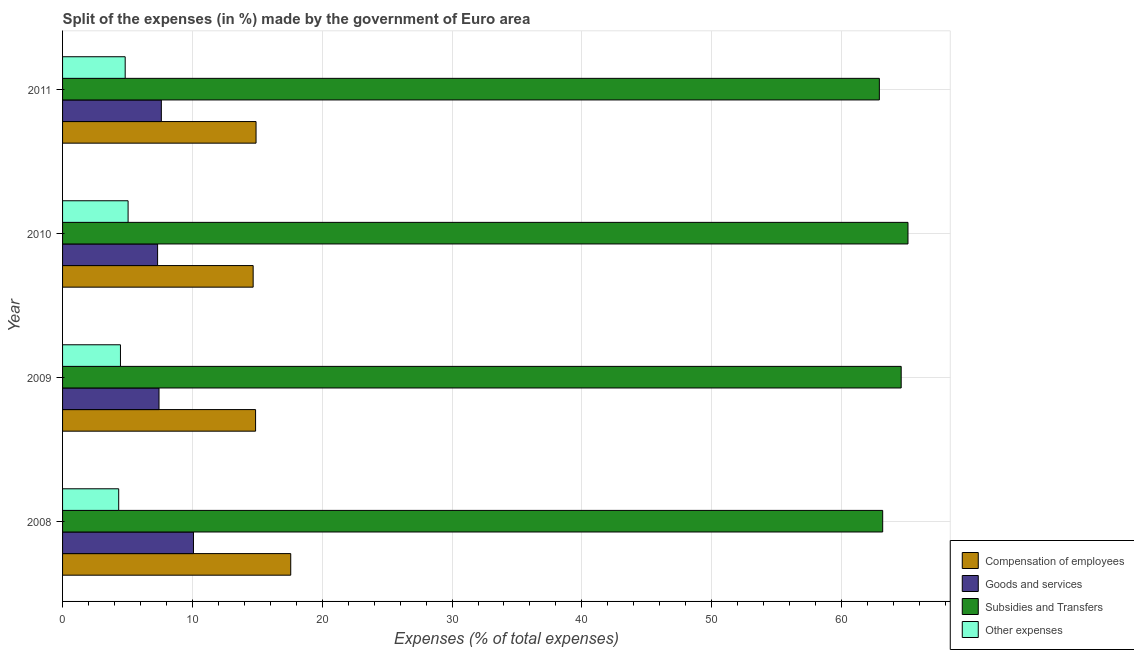How many groups of bars are there?
Ensure brevity in your answer.  4. Are the number of bars per tick equal to the number of legend labels?
Make the answer very short. Yes. How many bars are there on the 1st tick from the top?
Your answer should be very brief. 4. How many bars are there on the 2nd tick from the bottom?
Your answer should be very brief. 4. What is the percentage of amount spent on compensation of employees in 2008?
Make the answer very short. 17.57. Across all years, what is the maximum percentage of amount spent on compensation of employees?
Make the answer very short. 17.57. Across all years, what is the minimum percentage of amount spent on goods and services?
Give a very brief answer. 7.32. In which year was the percentage of amount spent on goods and services minimum?
Offer a terse response. 2010. What is the total percentage of amount spent on compensation of employees in the graph?
Your answer should be compact. 62.03. What is the difference between the percentage of amount spent on other expenses in 2008 and that in 2009?
Ensure brevity in your answer.  -0.14. What is the difference between the percentage of amount spent on subsidies in 2009 and the percentage of amount spent on other expenses in 2011?
Provide a succinct answer. 59.77. What is the average percentage of amount spent on subsidies per year?
Ensure brevity in your answer.  63.95. In the year 2010, what is the difference between the percentage of amount spent on goods and services and percentage of amount spent on compensation of employees?
Your response must be concise. -7.36. What is the ratio of the percentage of amount spent on goods and services in 2009 to that in 2011?
Ensure brevity in your answer.  0.98. Is the percentage of amount spent on compensation of employees in 2009 less than that in 2011?
Your answer should be very brief. Yes. What is the difference between the highest and the second highest percentage of amount spent on other expenses?
Your response must be concise. 0.22. What is the difference between the highest and the lowest percentage of amount spent on other expenses?
Your answer should be compact. 0.72. In how many years, is the percentage of amount spent on goods and services greater than the average percentage of amount spent on goods and services taken over all years?
Ensure brevity in your answer.  1. Is the sum of the percentage of amount spent on compensation of employees in 2009 and 2010 greater than the maximum percentage of amount spent on subsidies across all years?
Make the answer very short. No. What does the 4th bar from the top in 2009 represents?
Make the answer very short. Compensation of employees. What does the 1st bar from the bottom in 2009 represents?
Offer a terse response. Compensation of employees. Is it the case that in every year, the sum of the percentage of amount spent on compensation of employees and percentage of amount spent on goods and services is greater than the percentage of amount spent on subsidies?
Your answer should be very brief. No. Are all the bars in the graph horizontal?
Your answer should be very brief. Yes. How many years are there in the graph?
Give a very brief answer. 4. What is the difference between two consecutive major ticks on the X-axis?
Your answer should be compact. 10. Does the graph contain any zero values?
Your answer should be compact. No. Where does the legend appear in the graph?
Your answer should be compact. Bottom right. What is the title of the graph?
Provide a succinct answer. Split of the expenses (in %) made by the government of Euro area. What is the label or title of the X-axis?
Offer a terse response. Expenses (% of total expenses). What is the Expenses (% of total expenses) in Compensation of employees in 2008?
Ensure brevity in your answer.  17.57. What is the Expenses (% of total expenses) of Goods and services in 2008?
Keep it short and to the point. 10.08. What is the Expenses (% of total expenses) in Subsidies and Transfers in 2008?
Give a very brief answer. 63.17. What is the Expenses (% of total expenses) in Other expenses in 2008?
Give a very brief answer. 4.32. What is the Expenses (% of total expenses) in Compensation of employees in 2009?
Your answer should be very brief. 14.87. What is the Expenses (% of total expenses) in Goods and services in 2009?
Provide a succinct answer. 7.43. What is the Expenses (% of total expenses) of Subsidies and Transfers in 2009?
Ensure brevity in your answer.  64.59. What is the Expenses (% of total expenses) in Other expenses in 2009?
Provide a short and direct response. 4.46. What is the Expenses (% of total expenses) of Compensation of employees in 2010?
Provide a short and direct response. 14.68. What is the Expenses (% of total expenses) in Goods and services in 2010?
Ensure brevity in your answer.  7.32. What is the Expenses (% of total expenses) in Subsidies and Transfers in 2010?
Provide a short and direct response. 65.12. What is the Expenses (% of total expenses) in Other expenses in 2010?
Make the answer very short. 5.05. What is the Expenses (% of total expenses) in Compensation of employees in 2011?
Your response must be concise. 14.9. What is the Expenses (% of total expenses) of Goods and services in 2011?
Your response must be concise. 7.61. What is the Expenses (% of total expenses) in Subsidies and Transfers in 2011?
Ensure brevity in your answer.  62.91. What is the Expenses (% of total expenses) in Other expenses in 2011?
Give a very brief answer. 4.82. Across all years, what is the maximum Expenses (% of total expenses) of Compensation of employees?
Keep it short and to the point. 17.57. Across all years, what is the maximum Expenses (% of total expenses) of Goods and services?
Your answer should be compact. 10.08. Across all years, what is the maximum Expenses (% of total expenses) of Subsidies and Transfers?
Offer a very short reply. 65.12. Across all years, what is the maximum Expenses (% of total expenses) in Other expenses?
Give a very brief answer. 5.05. Across all years, what is the minimum Expenses (% of total expenses) in Compensation of employees?
Give a very brief answer. 14.68. Across all years, what is the minimum Expenses (% of total expenses) in Goods and services?
Your answer should be compact. 7.32. Across all years, what is the minimum Expenses (% of total expenses) of Subsidies and Transfers?
Your answer should be very brief. 62.91. Across all years, what is the minimum Expenses (% of total expenses) in Other expenses?
Give a very brief answer. 4.32. What is the total Expenses (% of total expenses) in Compensation of employees in the graph?
Offer a very short reply. 62.03. What is the total Expenses (% of total expenses) of Goods and services in the graph?
Your response must be concise. 32.44. What is the total Expenses (% of total expenses) in Subsidies and Transfers in the graph?
Provide a succinct answer. 255.8. What is the total Expenses (% of total expenses) of Other expenses in the graph?
Provide a succinct answer. 18.65. What is the difference between the Expenses (% of total expenses) in Compensation of employees in 2008 and that in 2009?
Your answer should be compact. 2.71. What is the difference between the Expenses (% of total expenses) in Goods and services in 2008 and that in 2009?
Your answer should be compact. 2.65. What is the difference between the Expenses (% of total expenses) of Subsidies and Transfers in 2008 and that in 2009?
Ensure brevity in your answer.  -1.42. What is the difference between the Expenses (% of total expenses) in Other expenses in 2008 and that in 2009?
Offer a terse response. -0.13. What is the difference between the Expenses (% of total expenses) in Compensation of employees in 2008 and that in 2010?
Your answer should be very brief. 2.89. What is the difference between the Expenses (% of total expenses) of Goods and services in 2008 and that in 2010?
Give a very brief answer. 2.76. What is the difference between the Expenses (% of total expenses) of Subsidies and Transfers in 2008 and that in 2010?
Provide a short and direct response. -1.95. What is the difference between the Expenses (% of total expenses) of Other expenses in 2008 and that in 2010?
Your answer should be compact. -0.72. What is the difference between the Expenses (% of total expenses) in Compensation of employees in 2008 and that in 2011?
Your answer should be very brief. 2.67. What is the difference between the Expenses (% of total expenses) of Goods and services in 2008 and that in 2011?
Ensure brevity in your answer.  2.47. What is the difference between the Expenses (% of total expenses) in Subsidies and Transfers in 2008 and that in 2011?
Make the answer very short. 0.26. What is the difference between the Expenses (% of total expenses) in Other expenses in 2008 and that in 2011?
Give a very brief answer. -0.5. What is the difference between the Expenses (% of total expenses) of Compensation of employees in 2009 and that in 2010?
Offer a terse response. 0.19. What is the difference between the Expenses (% of total expenses) of Goods and services in 2009 and that in 2010?
Provide a succinct answer. 0.11. What is the difference between the Expenses (% of total expenses) in Subsidies and Transfers in 2009 and that in 2010?
Offer a terse response. -0.52. What is the difference between the Expenses (% of total expenses) of Other expenses in 2009 and that in 2010?
Make the answer very short. -0.59. What is the difference between the Expenses (% of total expenses) in Compensation of employees in 2009 and that in 2011?
Provide a short and direct response. -0.04. What is the difference between the Expenses (% of total expenses) of Goods and services in 2009 and that in 2011?
Your answer should be very brief. -0.18. What is the difference between the Expenses (% of total expenses) in Subsidies and Transfers in 2009 and that in 2011?
Give a very brief answer. 1.68. What is the difference between the Expenses (% of total expenses) in Other expenses in 2009 and that in 2011?
Provide a succinct answer. -0.36. What is the difference between the Expenses (% of total expenses) in Compensation of employees in 2010 and that in 2011?
Make the answer very short. -0.22. What is the difference between the Expenses (% of total expenses) of Goods and services in 2010 and that in 2011?
Offer a terse response. -0.29. What is the difference between the Expenses (% of total expenses) in Subsidies and Transfers in 2010 and that in 2011?
Offer a terse response. 2.21. What is the difference between the Expenses (% of total expenses) in Other expenses in 2010 and that in 2011?
Give a very brief answer. 0.22. What is the difference between the Expenses (% of total expenses) of Compensation of employees in 2008 and the Expenses (% of total expenses) of Goods and services in 2009?
Provide a short and direct response. 10.15. What is the difference between the Expenses (% of total expenses) in Compensation of employees in 2008 and the Expenses (% of total expenses) in Subsidies and Transfers in 2009?
Make the answer very short. -47.02. What is the difference between the Expenses (% of total expenses) in Compensation of employees in 2008 and the Expenses (% of total expenses) in Other expenses in 2009?
Offer a terse response. 13.12. What is the difference between the Expenses (% of total expenses) of Goods and services in 2008 and the Expenses (% of total expenses) of Subsidies and Transfers in 2009?
Your answer should be compact. -54.51. What is the difference between the Expenses (% of total expenses) in Goods and services in 2008 and the Expenses (% of total expenses) in Other expenses in 2009?
Ensure brevity in your answer.  5.62. What is the difference between the Expenses (% of total expenses) of Subsidies and Transfers in 2008 and the Expenses (% of total expenses) of Other expenses in 2009?
Your answer should be very brief. 58.71. What is the difference between the Expenses (% of total expenses) of Compensation of employees in 2008 and the Expenses (% of total expenses) of Goods and services in 2010?
Your response must be concise. 10.25. What is the difference between the Expenses (% of total expenses) in Compensation of employees in 2008 and the Expenses (% of total expenses) in Subsidies and Transfers in 2010?
Your answer should be compact. -47.54. What is the difference between the Expenses (% of total expenses) of Compensation of employees in 2008 and the Expenses (% of total expenses) of Other expenses in 2010?
Your answer should be very brief. 12.53. What is the difference between the Expenses (% of total expenses) in Goods and services in 2008 and the Expenses (% of total expenses) in Subsidies and Transfers in 2010?
Your answer should be compact. -55.04. What is the difference between the Expenses (% of total expenses) of Goods and services in 2008 and the Expenses (% of total expenses) of Other expenses in 2010?
Ensure brevity in your answer.  5.04. What is the difference between the Expenses (% of total expenses) of Subsidies and Transfers in 2008 and the Expenses (% of total expenses) of Other expenses in 2010?
Your response must be concise. 58.12. What is the difference between the Expenses (% of total expenses) of Compensation of employees in 2008 and the Expenses (% of total expenses) of Goods and services in 2011?
Your answer should be compact. 9.97. What is the difference between the Expenses (% of total expenses) in Compensation of employees in 2008 and the Expenses (% of total expenses) in Subsidies and Transfers in 2011?
Give a very brief answer. -45.34. What is the difference between the Expenses (% of total expenses) in Compensation of employees in 2008 and the Expenses (% of total expenses) in Other expenses in 2011?
Give a very brief answer. 12.75. What is the difference between the Expenses (% of total expenses) in Goods and services in 2008 and the Expenses (% of total expenses) in Subsidies and Transfers in 2011?
Make the answer very short. -52.83. What is the difference between the Expenses (% of total expenses) in Goods and services in 2008 and the Expenses (% of total expenses) in Other expenses in 2011?
Offer a very short reply. 5.26. What is the difference between the Expenses (% of total expenses) of Subsidies and Transfers in 2008 and the Expenses (% of total expenses) of Other expenses in 2011?
Offer a terse response. 58.35. What is the difference between the Expenses (% of total expenses) in Compensation of employees in 2009 and the Expenses (% of total expenses) in Goods and services in 2010?
Provide a short and direct response. 7.55. What is the difference between the Expenses (% of total expenses) of Compensation of employees in 2009 and the Expenses (% of total expenses) of Subsidies and Transfers in 2010?
Offer a very short reply. -50.25. What is the difference between the Expenses (% of total expenses) in Compensation of employees in 2009 and the Expenses (% of total expenses) in Other expenses in 2010?
Provide a short and direct response. 9.82. What is the difference between the Expenses (% of total expenses) in Goods and services in 2009 and the Expenses (% of total expenses) in Subsidies and Transfers in 2010?
Provide a short and direct response. -57.69. What is the difference between the Expenses (% of total expenses) in Goods and services in 2009 and the Expenses (% of total expenses) in Other expenses in 2010?
Make the answer very short. 2.38. What is the difference between the Expenses (% of total expenses) in Subsidies and Transfers in 2009 and the Expenses (% of total expenses) in Other expenses in 2010?
Ensure brevity in your answer.  59.55. What is the difference between the Expenses (% of total expenses) of Compensation of employees in 2009 and the Expenses (% of total expenses) of Goods and services in 2011?
Your response must be concise. 7.26. What is the difference between the Expenses (% of total expenses) of Compensation of employees in 2009 and the Expenses (% of total expenses) of Subsidies and Transfers in 2011?
Provide a short and direct response. -48.05. What is the difference between the Expenses (% of total expenses) of Compensation of employees in 2009 and the Expenses (% of total expenses) of Other expenses in 2011?
Give a very brief answer. 10.04. What is the difference between the Expenses (% of total expenses) of Goods and services in 2009 and the Expenses (% of total expenses) of Subsidies and Transfers in 2011?
Offer a very short reply. -55.48. What is the difference between the Expenses (% of total expenses) in Goods and services in 2009 and the Expenses (% of total expenses) in Other expenses in 2011?
Your answer should be compact. 2.61. What is the difference between the Expenses (% of total expenses) in Subsidies and Transfers in 2009 and the Expenses (% of total expenses) in Other expenses in 2011?
Offer a terse response. 59.77. What is the difference between the Expenses (% of total expenses) in Compensation of employees in 2010 and the Expenses (% of total expenses) in Goods and services in 2011?
Make the answer very short. 7.07. What is the difference between the Expenses (% of total expenses) of Compensation of employees in 2010 and the Expenses (% of total expenses) of Subsidies and Transfers in 2011?
Offer a very short reply. -48.23. What is the difference between the Expenses (% of total expenses) in Compensation of employees in 2010 and the Expenses (% of total expenses) in Other expenses in 2011?
Provide a short and direct response. 9.86. What is the difference between the Expenses (% of total expenses) in Goods and services in 2010 and the Expenses (% of total expenses) in Subsidies and Transfers in 2011?
Ensure brevity in your answer.  -55.59. What is the difference between the Expenses (% of total expenses) in Goods and services in 2010 and the Expenses (% of total expenses) in Other expenses in 2011?
Provide a short and direct response. 2.5. What is the difference between the Expenses (% of total expenses) of Subsidies and Transfers in 2010 and the Expenses (% of total expenses) of Other expenses in 2011?
Make the answer very short. 60.29. What is the average Expenses (% of total expenses) in Compensation of employees per year?
Make the answer very short. 15.51. What is the average Expenses (% of total expenses) of Goods and services per year?
Offer a terse response. 8.11. What is the average Expenses (% of total expenses) of Subsidies and Transfers per year?
Give a very brief answer. 63.95. What is the average Expenses (% of total expenses) in Other expenses per year?
Provide a succinct answer. 4.66. In the year 2008, what is the difference between the Expenses (% of total expenses) in Compensation of employees and Expenses (% of total expenses) in Goods and services?
Keep it short and to the point. 7.49. In the year 2008, what is the difference between the Expenses (% of total expenses) of Compensation of employees and Expenses (% of total expenses) of Subsidies and Transfers?
Keep it short and to the point. -45.6. In the year 2008, what is the difference between the Expenses (% of total expenses) of Compensation of employees and Expenses (% of total expenses) of Other expenses?
Keep it short and to the point. 13.25. In the year 2008, what is the difference between the Expenses (% of total expenses) in Goods and services and Expenses (% of total expenses) in Subsidies and Transfers?
Provide a short and direct response. -53.09. In the year 2008, what is the difference between the Expenses (% of total expenses) in Goods and services and Expenses (% of total expenses) in Other expenses?
Offer a very short reply. 5.76. In the year 2008, what is the difference between the Expenses (% of total expenses) in Subsidies and Transfers and Expenses (% of total expenses) in Other expenses?
Give a very brief answer. 58.85. In the year 2009, what is the difference between the Expenses (% of total expenses) of Compensation of employees and Expenses (% of total expenses) of Goods and services?
Your answer should be very brief. 7.44. In the year 2009, what is the difference between the Expenses (% of total expenses) in Compensation of employees and Expenses (% of total expenses) in Subsidies and Transfers?
Make the answer very short. -49.73. In the year 2009, what is the difference between the Expenses (% of total expenses) of Compensation of employees and Expenses (% of total expenses) of Other expenses?
Give a very brief answer. 10.41. In the year 2009, what is the difference between the Expenses (% of total expenses) of Goods and services and Expenses (% of total expenses) of Subsidies and Transfers?
Make the answer very short. -57.17. In the year 2009, what is the difference between the Expenses (% of total expenses) in Goods and services and Expenses (% of total expenses) in Other expenses?
Ensure brevity in your answer.  2.97. In the year 2009, what is the difference between the Expenses (% of total expenses) in Subsidies and Transfers and Expenses (% of total expenses) in Other expenses?
Provide a succinct answer. 60.14. In the year 2010, what is the difference between the Expenses (% of total expenses) in Compensation of employees and Expenses (% of total expenses) in Goods and services?
Your response must be concise. 7.36. In the year 2010, what is the difference between the Expenses (% of total expenses) in Compensation of employees and Expenses (% of total expenses) in Subsidies and Transfers?
Offer a terse response. -50.44. In the year 2010, what is the difference between the Expenses (% of total expenses) in Compensation of employees and Expenses (% of total expenses) in Other expenses?
Your response must be concise. 9.63. In the year 2010, what is the difference between the Expenses (% of total expenses) of Goods and services and Expenses (% of total expenses) of Subsidies and Transfers?
Ensure brevity in your answer.  -57.8. In the year 2010, what is the difference between the Expenses (% of total expenses) in Goods and services and Expenses (% of total expenses) in Other expenses?
Your response must be concise. 2.27. In the year 2010, what is the difference between the Expenses (% of total expenses) of Subsidies and Transfers and Expenses (% of total expenses) of Other expenses?
Give a very brief answer. 60.07. In the year 2011, what is the difference between the Expenses (% of total expenses) of Compensation of employees and Expenses (% of total expenses) of Goods and services?
Offer a terse response. 7.29. In the year 2011, what is the difference between the Expenses (% of total expenses) of Compensation of employees and Expenses (% of total expenses) of Subsidies and Transfers?
Offer a terse response. -48.01. In the year 2011, what is the difference between the Expenses (% of total expenses) of Compensation of employees and Expenses (% of total expenses) of Other expenses?
Provide a short and direct response. 10.08. In the year 2011, what is the difference between the Expenses (% of total expenses) of Goods and services and Expenses (% of total expenses) of Subsidies and Transfers?
Your response must be concise. -55.3. In the year 2011, what is the difference between the Expenses (% of total expenses) in Goods and services and Expenses (% of total expenses) in Other expenses?
Make the answer very short. 2.79. In the year 2011, what is the difference between the Expenses (% of total expenses) of Subsidies and Transfers and Expenses (% of total expenses) of Other expenses?
Your answer should be very brief. 58.09. What is the ratio of the Expenses (% of total expenses) in Compensation of employees in 2008 to that in 2009?
Ensure brevity in your answer.  1.18. What is the ratio of the Expenses (% of total expenses) of Goods and services in 2008 to that in 2009?
Offer a terse response. 1.36. What is the ratio of the Expenses (% of total expenses) in Subsidies and Transfers in 2008 to that in 2009?
Offer a terse response. 0.98. What is the ratio of the Expenses (% of total expenses) in Other expenses in 2008 to that in 2009?
Offer a very short reply. 0.97. What is the ratio of the Expenses (% of total expenses) in Compensation of employees in 2008 to that in 2010?
Your answer should be very brief. 1.2. What is the ratio of the Expenses (% of total expenses) in Goods and services in 2008 to that in 2010?
Provide a short and direct response. 1.38. What is the ratio of the Expenses (% of total expenses) of Subsidies and Transfers in 2008 to that in 2010?
Your answer should be very brief. 0.97. What is the ratio of the Expenses (% of total expenses) in Other expenses in 2008 to that in 2010?
Give a very brief answer. 0.86. What is the ratio of the Expenses (% of total expenses) of Compensation of employees in 2008 to that in 2011?
Your response must be concise. 1.18. What is the ratio of the Expenses (% of total expenses) of Goods and services in 2008 to that in 2011?
Make the answer very short. 1.33. What is the ratio of the Expenses (% of total expenses) of Other expenses in 2008 to that in 2011?
Your answer should be compact. 0.9. What is the ratio of the Expenses (% of total expenses) in Compensation of employees in 2009 to that in 2010?
Your answer should be compact. 1.01. What is the ratio of the Expenses (% of total expenses) in Goods and services in 2009 to that in 2010?
Offer a very short reply. 1.01. What is the ratio of the Expenses (% of total expenses) of Other expenses in 2009 to that in 2010?
Provide a short and direct response. 0.88. What is the ratio of the Expenses (% of total expenses) in Goods and services in 2009 to that in 2011?
Ensure brevity in your answer.  0.98. What is the ratio of the Expenses (% of total expenses) in Subsidies and Transfers in 2009 to that in 2011?
Provide a succinct answer. 1.03. What is the ratio of the Expenses (% of total expenses) in Other expenses in 2009 to that in 2011?
Ensure brevity in your answer.  0.92. What is the ratio of the Expenses (% of total expenses) in Compensation of employees in 2010 to that in 2011?
Ensure brevity in your answer.  0.98. What is the ratio of the Expenses (% of total expenses) of Goods and services in 2010 to that in 2011?
Make the answer very short. 0.96. What is the ratio of the Expenses (% of total expenses) of Subsidies and Transfers in 2010 to that in 2011?
Provide a short and direct response. 1.04. What is the ratio of the Expenses (% of total expenses) in Other expenses in 2010 to that in 2011?
Your answer should be compact. 1.05. What is the difference between the highest and the second highest Expenses (% of total expenses) in Compensation of employees?
Offer a terse response. 2.67. What is the difference between the highest and the second highest Expenses (% of total expenses) of Goods and services?
Offer a very short reply. 2.47. What is the difference between the highest and the second highest Expenses (% of total expenses) of Subsidies and Transfers?
Ensure brevity in your answer.  0.52. What is the difference between the highest and the second highest Expenses (% of total expenses) in Other expenses?
Your answer should be compact. 0.22. What is the difference between the highest and the lowest Expenses (% of total expenses) of Compensation of employees?
Give a very brief answer. 2.89. What is the difference between the highest and the lowest Expenses (% of total expenses) of Goods and services?
Provide a short and direct response. 2.76. What is the difference between the highest and the lowest Expenses (% of total expenses) of Subsidies and Transfers?
Give a very brief answer. 2.21. What is the difference between the highest and the lowest Expenses (% of total expenses) of Other expenses?
Make the answer very short. 0.72. 